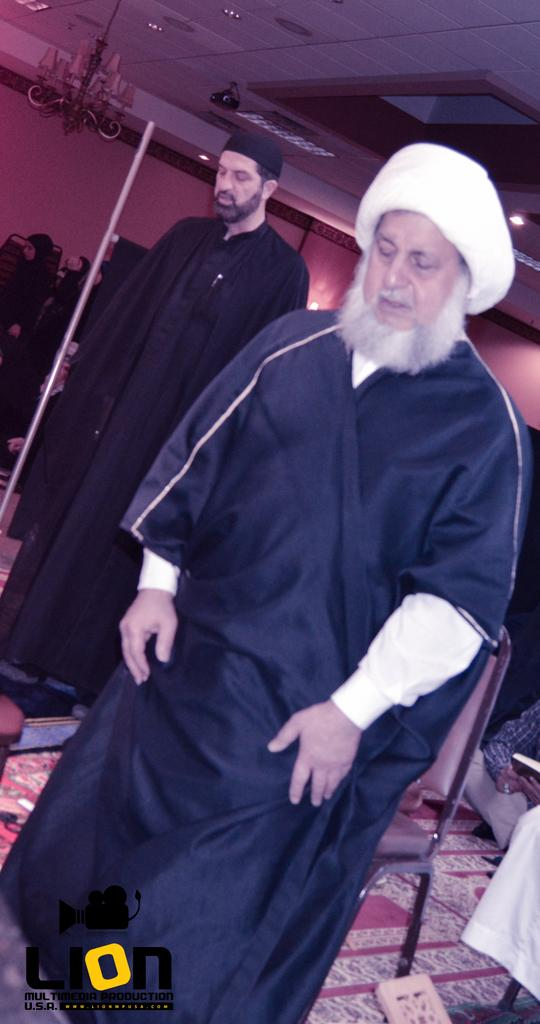Who or what is present in the image? There are people in the image. What is located at the bottom of the image? There is a carpet at the bottom of the image. Where is the chandelier situated in the image? The chandelier is on the left side of the image. What type of illumination can be seen in the image? There are lights in the image. What can be seen in the background of the image? There is a wall in the background of the image. What type of headwear is the grandmother wearing in the image? There is no grandmother present in the image, and therefore no headwear can be observed. 